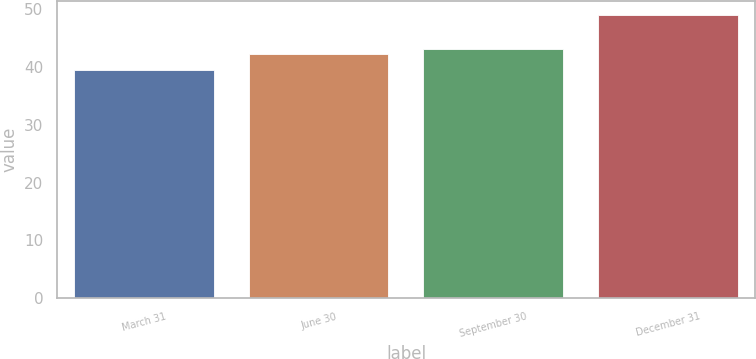Convert chart to OTSL. <chart><loc_0><loc_0><loc_500><loc_500><bar_chart><fcel>March 31<fcel>June 30<fcel>September 30<fcel>December 31<nl><fcel>39.52<fcel>42.19<fcel>43.14<fcel>48.95<nl></chart> 